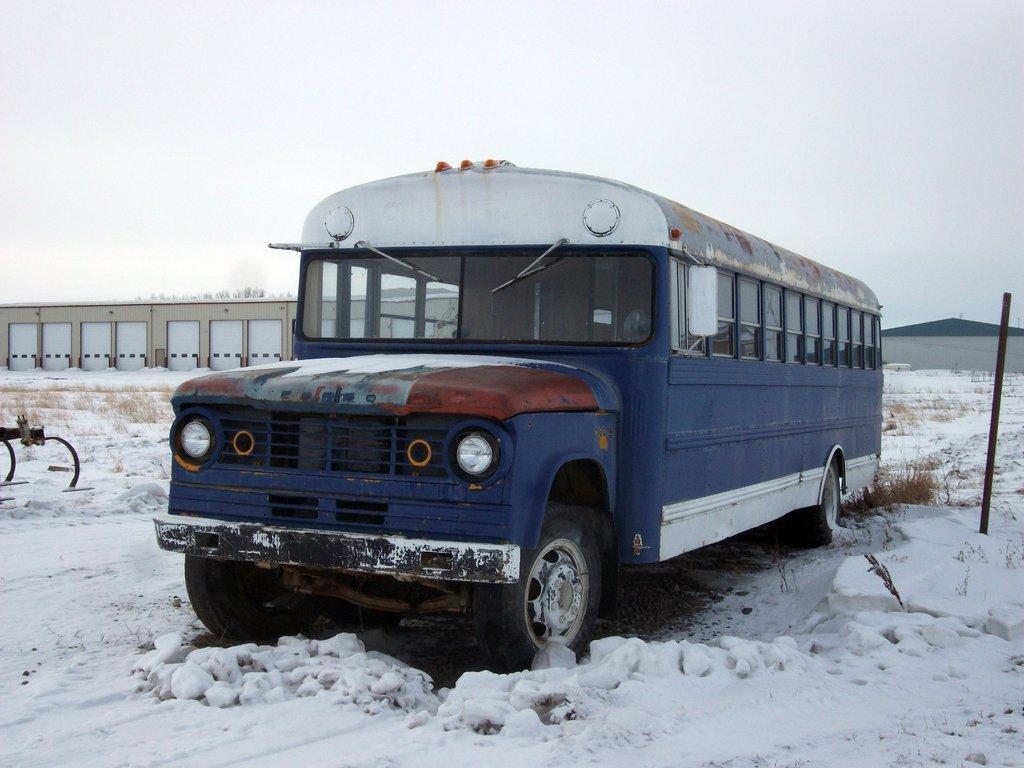In one or two sentences, can you explain what this image depicts? In the picture I can see a blue color bus on the road. Here we can see the road is covered with snow. In the background, I can see a house and the plain sky. 